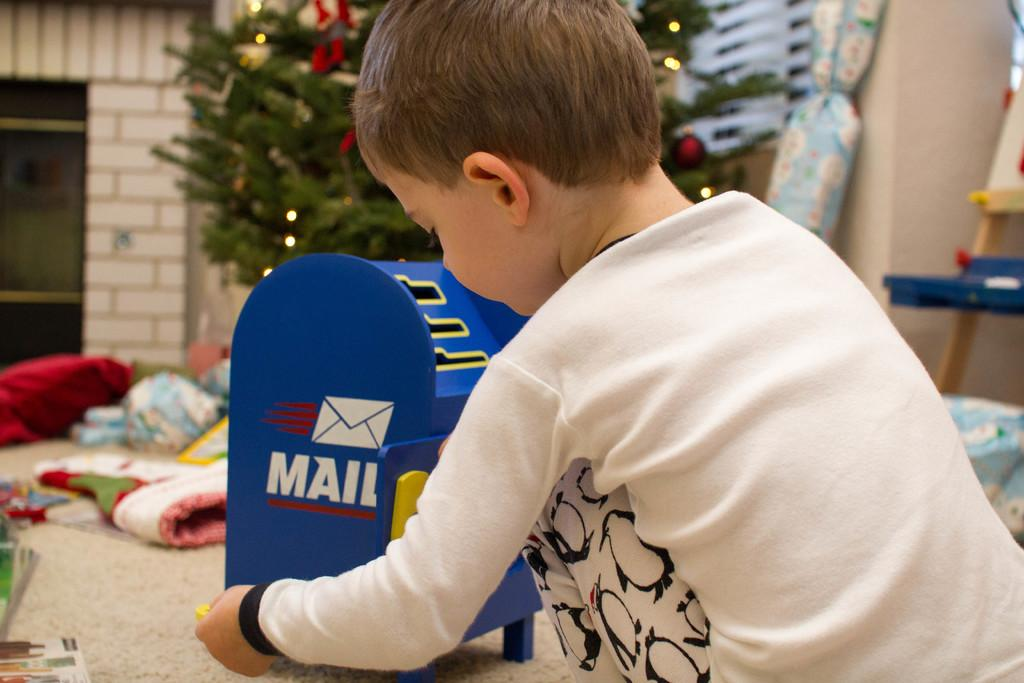Who is the main subject in the image? There is a boy in the image. What is the boy wearing? The boy is wearing a white t-shirt. What is the boy doing in the image? The boy is playing with a blue box. What can be seen in the background of the image? There is a Christmas tree, a wall, and a chair in the background. What type of frame surrounds the boy in the image? There is no frame surrounding the boy in the image; it is a photograph or digital image without a frame. 